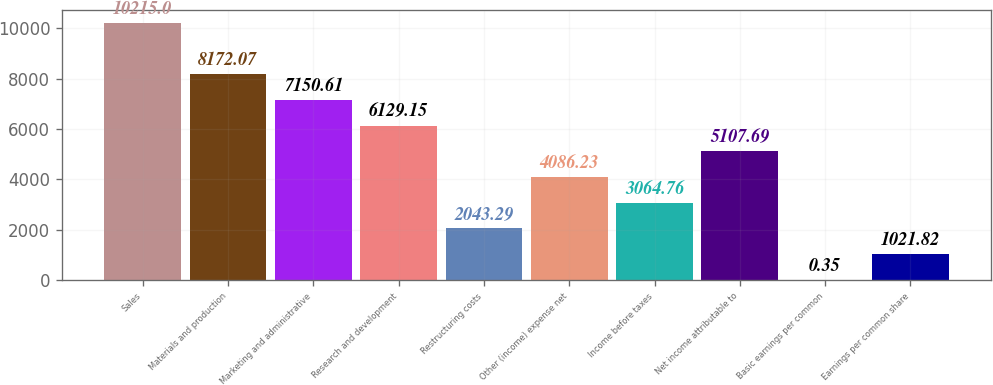<chart> <loc_0><loc_0><loc_500><loc_500><bar_chart><fcel>Sales<fcel>Materials and production<fcel>Marketing and administrative<fcel>Research and development<fcel>Restructuring costs<fcel>Other (income) expense net<fcel>Income before taxes<fcel>Net income attributable to<fcel>Basic earnings per common<fcel>Earnings per common share<nl><fcel>10215<fcel>8172.07<fcel>7150.61<fcel>6129.15<fcel>2043.29<fcel>4086.23<fcel>3064.76<fcel>5107.69<fcel>0.35<fcel>1021.82<nl></chart> 